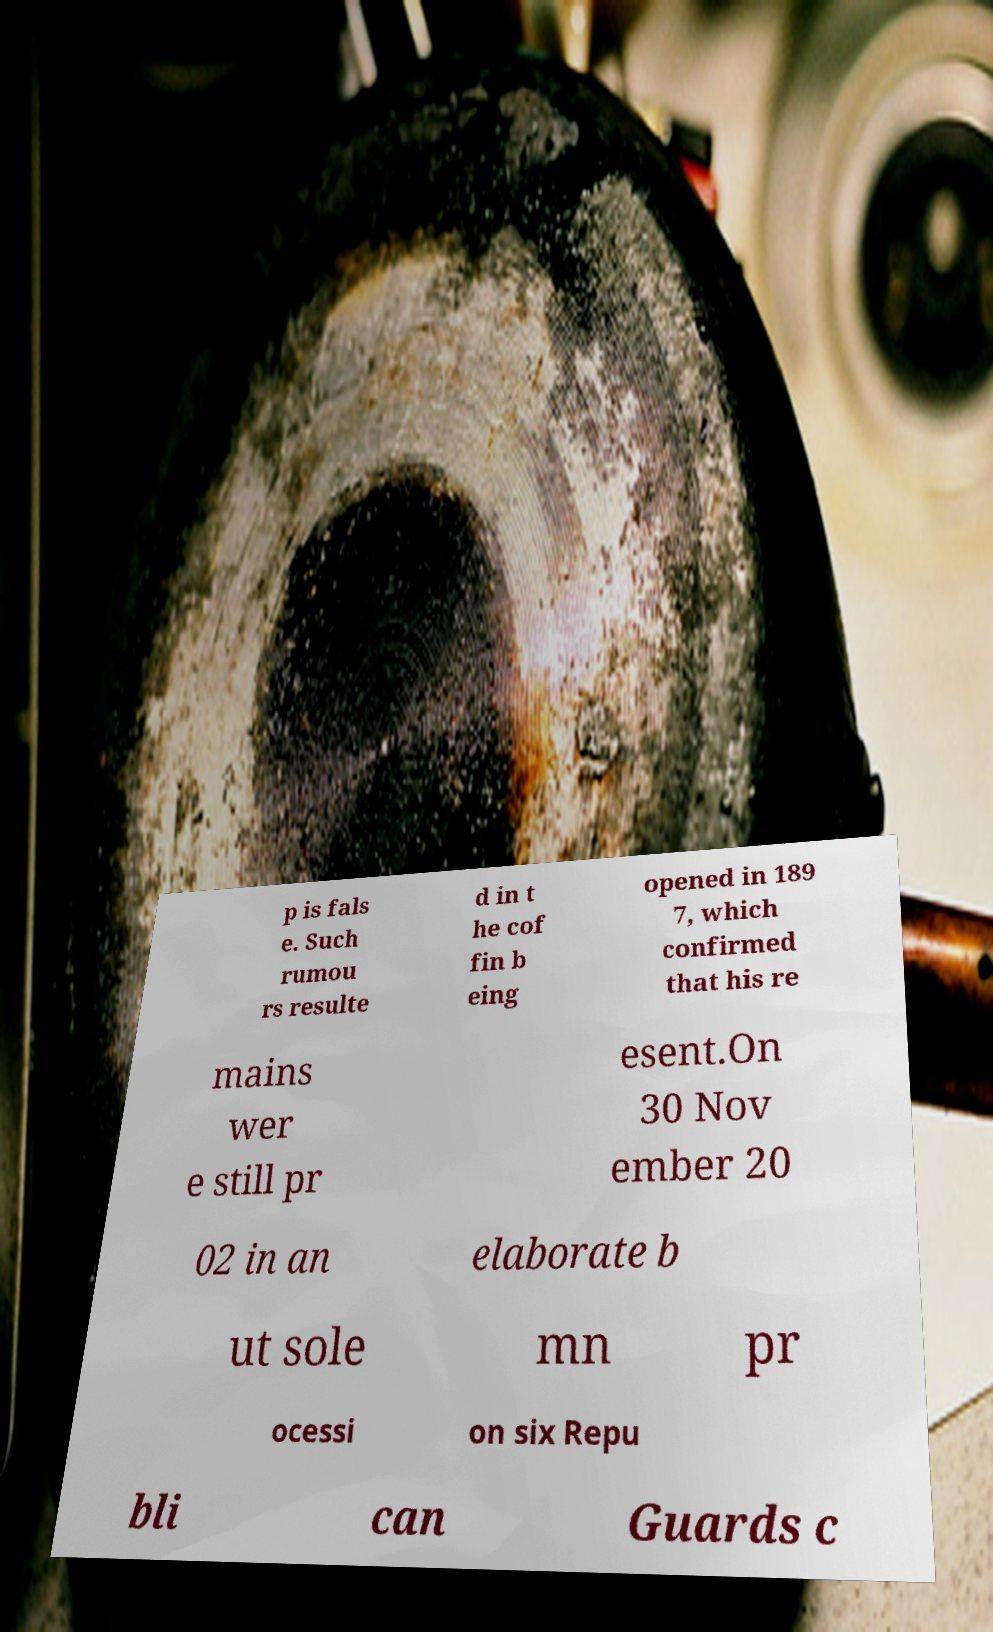Can you read and provide the text displayed in the image?This photo seems to have some interesting text. Can you extract and type it out for me? p is fals e. Such rumou rs resulte d in t he cof fin b eing opened in 189 7, which confirmed that his re mains wer e still pr esent.On 30 Nov ember 20 02 in an elaborate b ut sole mn pr ocessi on six Repu bli can Guards c 